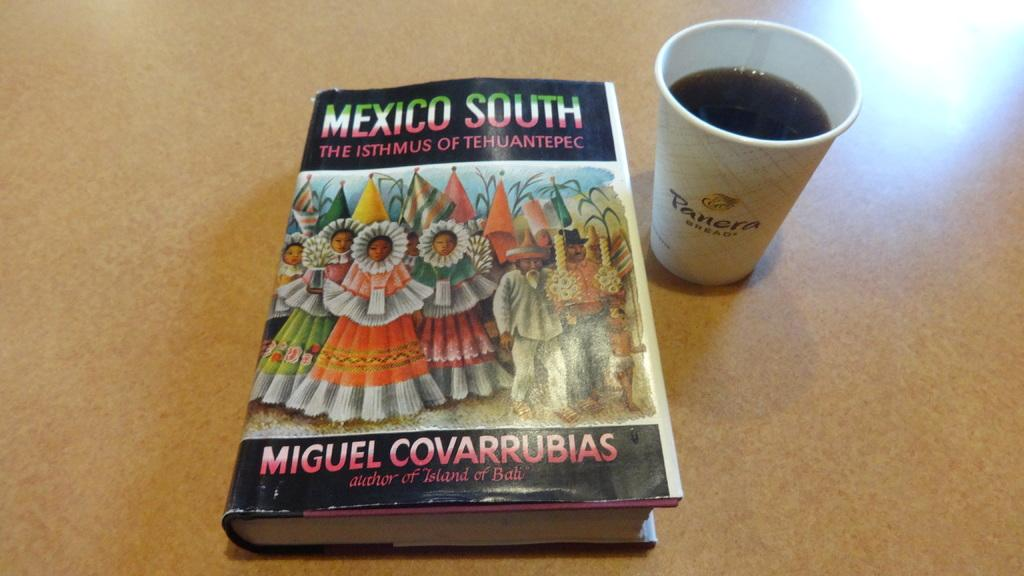<image>
Provide a brief description of the given image. A black book with women on the front titled Mexico South. 